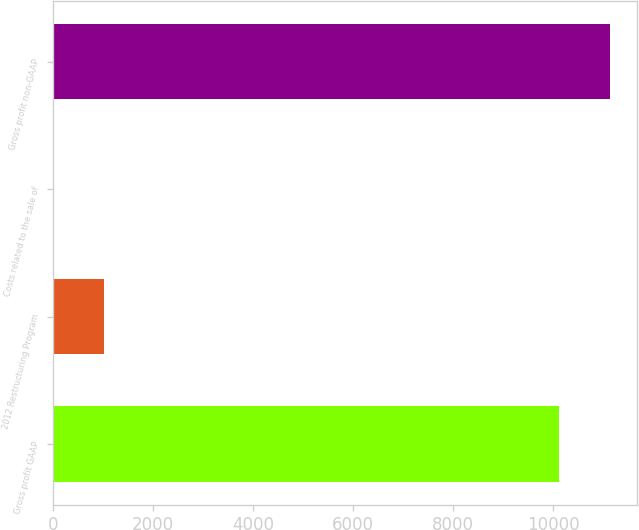Convert chart. <chart><loc_0><loc_0><loc_500><loc_500><bar_chart><fcel>Gross profit GAAP<fcel>2012 Restructuring Program<fcel>Costs related to the sale of<fcel>Gross profit non-GAAP<nl><fcel>10109<fcel>1017.8<fcel>4<fcel>11122.8<nl></chart> 